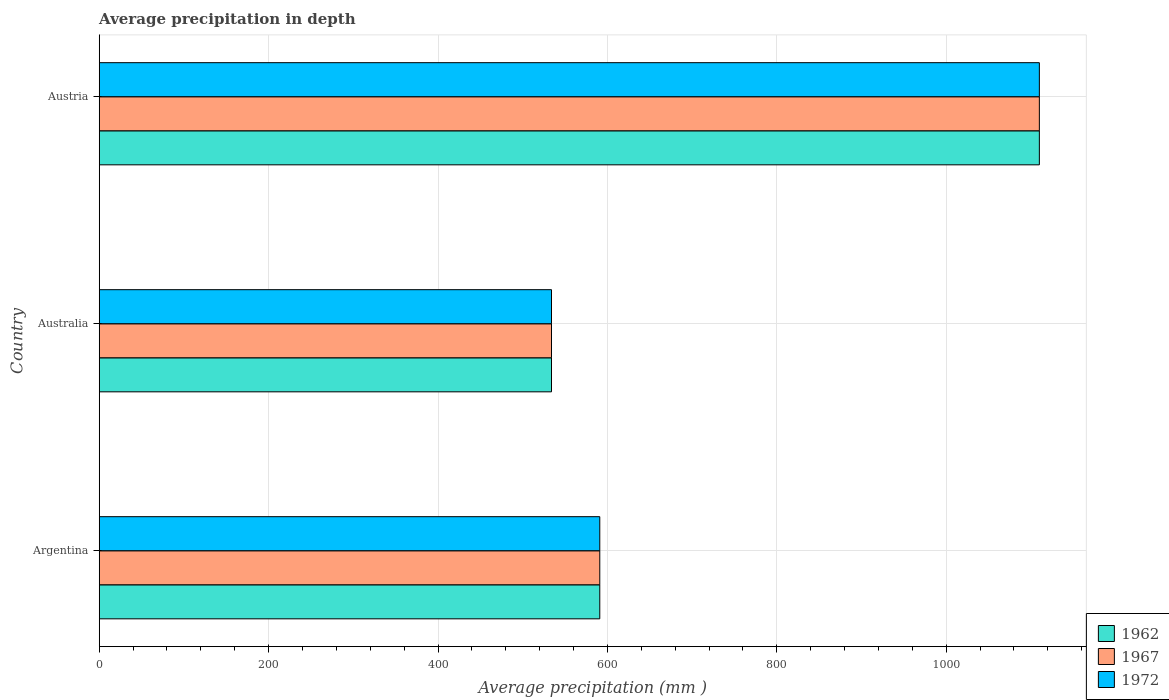How many different coloured bars are there?
Your answer should be compact. 3. Are the number of bars on each tick of the Y-axis equal?
Give a very brief answer. Yes. How many bars are there on the 2nd tick from the top?
Your response must be concise. 3. How many bars are there on the 1st tick from the bottom?
Give a very brief answer. 3. What is the label of the 2nd group of bars from the top?
Offer a terse response. Australia. What is the average precipitation in 1967 in Australia?
Provide a succinct answer. 534. Across all countries, what is the maximum average precipitation in 1972?
Keep it short and to the point. 1110. Across all countries, what is the minimum average precipitation in 1972?
Offer a terse response. 534. In which country was the average precipitation in 1972 maximum?
Your answer should be very brief. Austria. In which country was the average precipitation in 1962 minimum?
Provide a short and direct response. Australia. What is the total average precipitation in 1967 in the graph?
Your response must be concise. 2235. What is the difference between the average precipitation in 1962 in Argentina and that in Australia?
Ensure brevity in your answer.  57. What is the difference between the average precipitation in 1967 in Australia and the average precipitation in 1972 in Austria?
Make the answer very short. -576. What is the average average precipitation in 1972 per country?
Give a very brief answer. 745. What is the ratio of the average precipitation in 1967 in Australia to that in Austria?
Your response must be concise. 0.48. Is the average precipitation in 1962 in Argentina less than that in Australia?
Keep it short and to the point. No. What is the difference between the highest and the second highest average precipitation in 1972?
Provide a succinct answer. 519. What is the difference between the highest and the lowest average precipitation in 1972?
Keep it short and to the point. 576. Is it the case that in every country, the sum of the average precipitation in 1972 and average precipitation in 1962 is greater than the average precipitation in 1967?
Offer a very short reply. Yes. What is the difference between two consecutive major ticks on the X-axis?
Your response must be concise. 200. Are the values on the major ticks of X-axis written in scientific E-notation?
Give a very brief answer. No. Does the graph contain any zero values?
Offer a terse response. No. Does the graph contain grids?
Offer a very short reply. Yes. Where does the legend appear in the graph?
Your answer should be very brief. Bottom right. How many legend labels are there?
Give a very brief answer. 3. What is the title of the graph?
Your answer should be compact. Average precipitation in depth. Does "1997" appear as one of the legend labels in the graph?
Make the answer very short. No. What is the label or title of the X-axis?
Your answer should be very brief. Average precipitation (mm ). What is the Average precipitation (mm ) in 1962 in Argentina?
Offer a terse response. 591. What is the Average precipitation (mm ) in 1967 in Argentina?
Give a very brief answer. 591. What is the Average precipitation (mm ) of 1972 in Argentina?
Offer a very short reply. 591. What is the Average precipitation (mm ) in 1962 in Australia?
Your answer should be compact. 534. What is the Average precipitation (mm ) of 1967 in Australia?
Provide a succinct answer. 534. What is the Average precipitation (mm ) in 1972 in Australia?
Your answer should be compact. 534. What is the Average precipitation (mm ) of 1962 in Austria?
Offer a terse response. 1110. What is the Average precipitation (mm ) of 1967 in Austria?
Offer a terse response. 1110. What is the Average precipitation (mm ) of 1972 in Austria?
Your answer should be compact. 1110. Across all countries, what is the maximum Average precipitation (mm ) in 1962?
Provide a succinct answer. 1110. Across all countries, what is the maximum Average precipitation (mm ) in 1967?
Make the answer very short. 1110. Across all countries, what is the maximum Average precipitation (mm ) of 1972?
Your answer should be very brief. 1110. Across all countries, what is the minimum Average precipitation (mm ) in 1962?
Offer a very short reply. 534. Across all countries, what is the minimum Average precipitation (mm ) in 1967?
Provide a short and direct response. 534. Across all countries, what is the minimum Average precipitation (mm ) of 1972?
Make the answer very short. 534. What is the total Average precipitation (mm ) of 1962 in the graph?
Make the answer very short. 2235. What is the total Average precipitation (mm ) of 1967 in the graph?
Ensure brevity in your answer.  2235. What is the total Average precipitation (mm ) of 1972 in the graph?
Provide a succinct answer. 2235. What is the difference between the Average precipitation (mm ) in 1967 in Argentina and that in Australia?
Your answer should be very brief. 57. What is the difference between the Average precipitation (mm ) in 1962 in Argentina and that in Austria?
Provide a succinct answer. -519. What is the difference between the Average precipitation (mm ) of 1967 in Argentina and that in Austria?
Your response must be concise. -519. What is the difference between the Average precipitation (mm ) in 1972 in Argentina and that in Austria?
Your answer should be compact. -519. What is the difference between the Average precipitation (mm ) in 1962 in Australia and that in Austria?
Your answer should be compact. -576. What is the difference between the Average precipitation (mm ) of 1967 in Australia and that in Austria?
Give a very brief answer. -576. What is the difference between the Average precipitation (mm ) in 1972 in Australia and that in Austria?
Give a very brief answer. -576. What is the difference between the Average precipitation (mm ) in 1962 in Argentina and the Average precipitation (mm ) in 1972 in Australia?
Your answer should be very brief. 57. What is the difference between the Average precipitation (mm ) in 1967 in Argentina and the Average precipitation (mm ) in 1972 in Australia?
Offer a terse response. 57. What is the difference between the Average precipitation (mm ) in 1962 in Argentina and the Average precipitation (mm ) in 1967 in Austria?
Give a very brief answer. -519. What is the difference between the Average precipitation (mm ) in 1962 in Argentina and the Average precipitation (mm ) in 1972 in Austria?
Keep it short and to the point. -519. What is the difference between the Average precipitation (mm ) in 1967 in Argentina and the Average precipitation (mm ) in 1972 in Austria?
Offer a very short reply. -519. What is the difference between the Average precipitation (mm ) in 1962 in Australia and the Average precipitation (mm ) in 1967 in Austria?
Offer a terse response. -576. What is the difference between the Average precipitation (mm ) of 1962 in Australia and the Average precipitation (mm ) of 1972 in Austria?
Offer a very short reply. -576. What is the difference between the Average precipitation (mm ) of 1967 in Australia and the Average precipitation (mm ) of 1972 in Austria?
Provide a short and direct response. -576. What is the average Average precipitation (mm ) of 1962 per country?
Make the answer very short. 745. What is the average Average precipitation (mm ) in 1967 per country?
Make the answer very short. 745. What is the average Average precipitation (mm ) in 1972 per country?
Your answer should be compact. 745. What is the difference between the Average precipitation (mm ) of 1962 and Average precipitation (mm ) of 1967 in Argentina?
Give a very brief answer. 0. What is the difference between the Average precipitation (mm ) in 1962 and Average precipitation (mm ) in 1972 in Argentina?
Offer a terse response. 0. What is the difference between the Average precipitation (mm ) of 1962 and Average precipitation (mm ) of 1967 in Australia?
Your answer should be compact. 0. What is the difference between the Average precipitation (mm ) in 1962 and Average precipitation (mm ) in 1972 in Australia?
Give a very brief answer. 0. What is the difference between the Average precipitation (mm ) of 1967 and Average precipitation (mm ) of 1972 in Australia?
Ensure brevity in your answer.  0. What is the difference between the Average precipitation (mm ) in 1962 and Average precipitation (mm ) in 1972 in Austria?
Your response must be concise. 0. What is the difference between the Average precipitation (mm ) in 1967 and Average precipitation (mm ) in 1972 in Austria?
Your response must be concise. 0. What is the ratio of the Average precipitation (mm ) of 1962 in Argentina to that in Australia?
Keep it short and to the point. 1.11. What is the ratio of the Average precipitation (mm ) of 1967 in Argentina to that in Australia?
Make the answer very short. 1.11. What is the ratio of the Average precipitation (mm ) in 1972 in Argentina to that in Australia?
Offer a terse response. 1.11. What is the ratio of the Average precipitation (mm ) in 1962 in Argentina to that in Austria?
Keep it short and to the point. 0.53. What is the ratio of the Average precipitation (mm ) of 1967 in Argentina to that in Austria?
Offer a very short reply. 0.53. What is the ratio of the Average precipitation (mm ) of 1972 in Argentina to that in Austria?
Your response must be concise. 0.53. What is the ratio of the Average precipitation (mm ) in 1962 in Australia to that in Austria?
Your response must be concise. 0.48. What is the ratio of the Average precipitation (mm ) of 1967 in Australia to that in Austria?
Offer a very short reply. 0.48. What is the ratio of the Average precipitation (mm ) in 1972 in Australia to that in Austria?
Ensure brevity in your answer.  0.48. What is the difference between the highest and the second highest Average precipitation (mm ) in 1962?
Make the answer very short. 519. What is the difference between the highest and the second highest Average precipitation (mm ) in 1967?
Offer a terse response. 519. What is the difference between the highest and the second highest Average precipitation (mm ) in 1972?
Make the answer very short. 519. What is the difference between the highest and the lowest Average precipitation (mm ) in 1962?
Offer a very short reply. 576. What is the difference between the highest and the lowest Average precipitation (mm ) in 1967?
Make the answer very short. 576. What is the difference between the highest and the lowest Average precipitation (mm ) in 1972?
Keep it short and to the point. 576. 